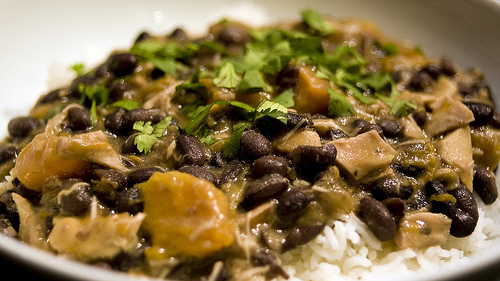<image>
Can you confirm if the beans is in the rice? No. The beans is not contained within the rice. These objects have a different spatial relationship. 